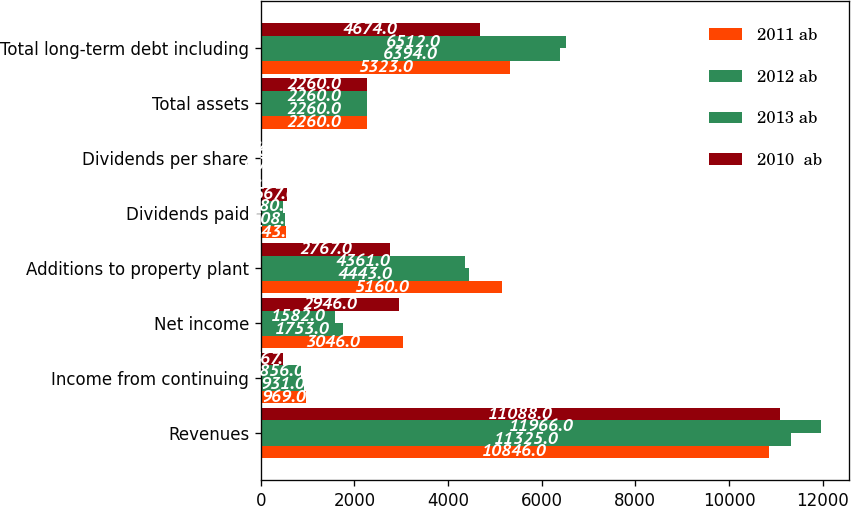Convert chart to OTSL. <chart><loc_0><loc_0><loc_500><loc_500><stacked_bar_chart><ecel><fcel>Revenues<fcel>Income from continuing<fcel>Net income<fcel>Additions to property plant<fcel>Dividends paid<fcel>Dividends per share<fcel>Total assets<fcel>Total long-term debt including<nl><fcel>2011 ab<fcel>10846<fcel>969<fcel>3046<fcel>5160<fcel>543<fcel>0.8<fcel>2260<fcel>5323<nl><fcel>2012 ab<fcel>11325<fcel>931<fcel>1753<fcel>4443<fcel>508<fcel>0.72<fcel>2260<fcel>6394<nl><fcel>2013 ab<fcel>11966<fcel>856<fcel>1582<fcel>4361<fcel>480<fcel>0.68<fcel>2260<fcel>6512<nl><fcel>2010  ab<fcel>11088<fcel>467<fcel>2946<fcel>2767<fcel>567<fcel>0.8<fcel>2260<fcel>4674<nl></chart> 